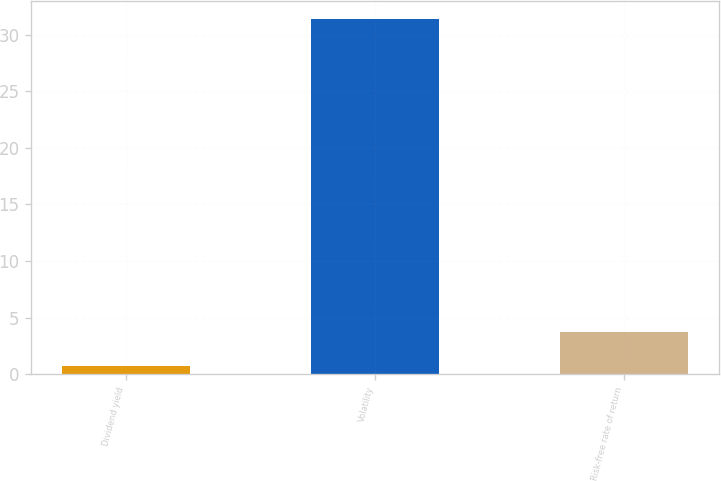<chart> <loc_0><loc_0><loc_500><loc_500><bar_chart><fcel>Dividend yield<fcel>Volatility<fcel>Risk-free rate of return<nl><fcel>0.69<fcel>31.37<fcel>3.76<nl></chart> 